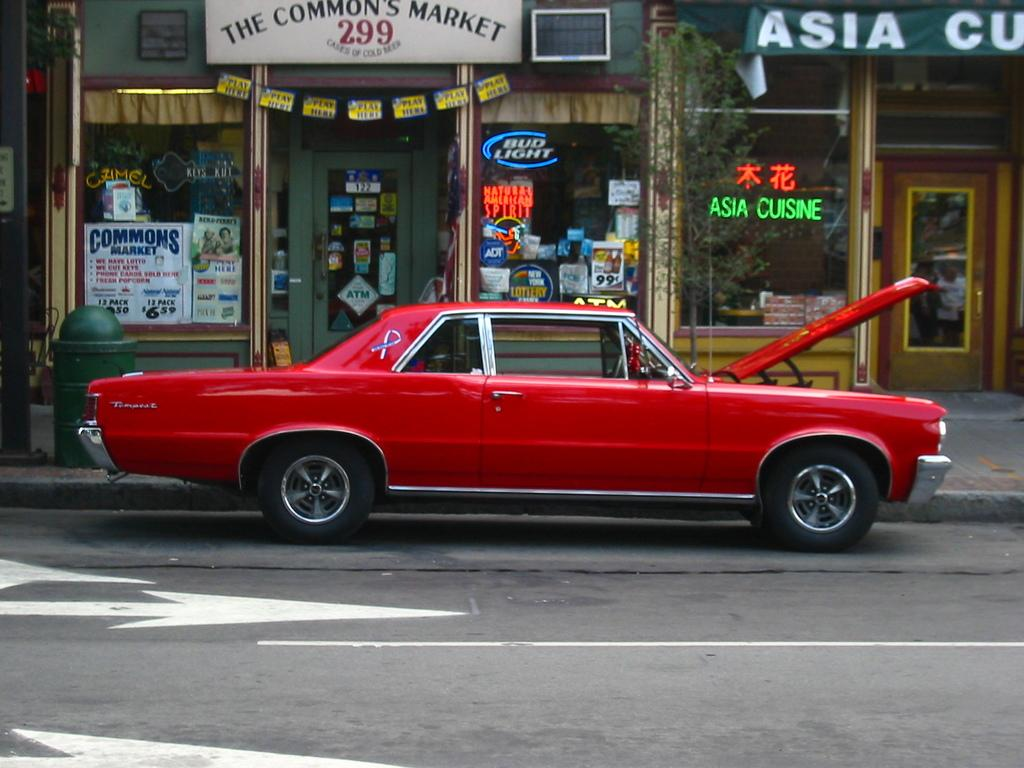<image>
Present a compact description of the photo's key features. A red car with its hood up in front of the commons market. 